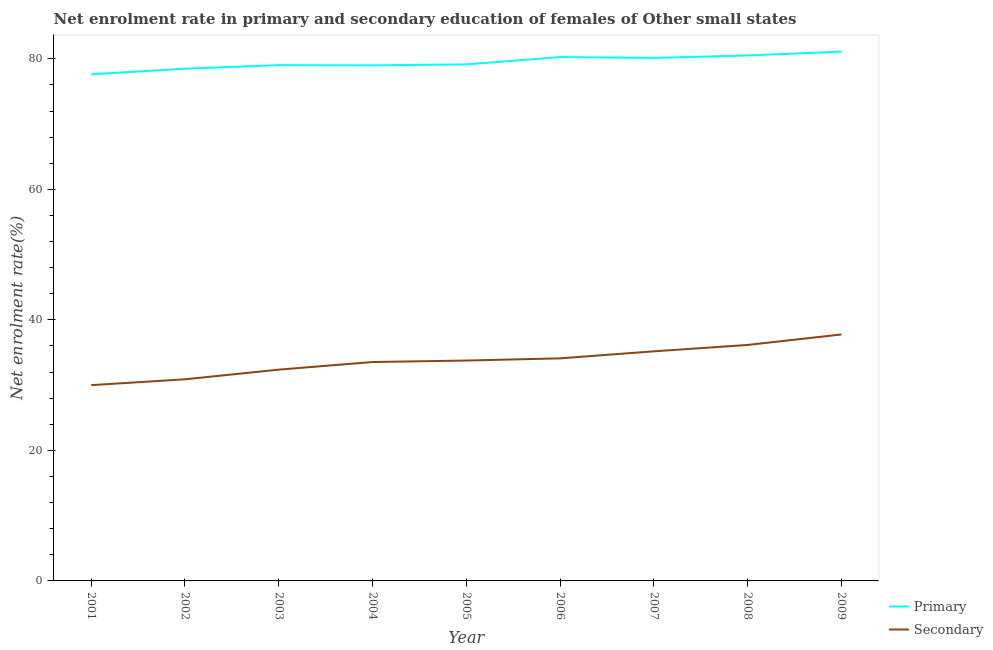Does the line corresponding to enrollment rate in primary education intersect with the line corresponding to enrollment rate in secondary education?
Give a very brief answer. No. What is the enrollment rate in primary education in 2003?
Provide a short and direct response. 79.03. Across all years, what is the maximum enrollment rate in primary education?
Provide a short and direct response. 81.11. Across all years, what is the minimum enrollment rate in secondary education?
Your answer should be compact. 30. What is the total enrollment rate in primary education in the graph?
Provide a succinct answer. 715.3. What is the difference between the enrollment rate in secondary education in 2004 and that in 2008?
Ensure brevity in your answer.  -2.61. What is the difference between the enrollment rate in primary education in 2009 and the enrollment rate in secondary education in 2007?
Your answer should be compact. 45.93. What is the average enrollment rate in primary education per year?
Ensure brevity in your answer.  79.48. In the year 2004, what is the difference between the enrollment rate in secondary education and enrollment rate in primary education?
Offer a very short reply. -45.45. In how many years, is the enrollment rate in primary education greater than 8 %?
Make the answer very short. 9. What is the ratio of the enrollment rate in primary education in 2004 to that in 2008?
Keep it short and to the point. 0.98. What is the difference between the highest and the second highest enrollment rate in primary education?
Ensure brevity in your answer.  0.6. What is the difference between the highest and the lowest enrollment rate in primary education?
Make the answer very short. 3.48. Does the enrollment rate in secondary education monotonically increase over the years?
Keep it short and to the point. Yes. Is the enrollment rate in secondary education strictly greater than the enrollment rate in primary education over the years?
Offer a very short reply. No. How many years are there in the graph?
Offer a very short reply. 9. How many legend labels are there?
Keep it short and to the point. 2. What is the title of the graph?
Your response must be concise. Net enrolment rate in primary and secondary education of females of Other small states. What is the label or title of the Y-axis?
Your response must be concise. Net enrolment rate(%). What is the Net enrolment rate(%) in Primary in 2001?
Offer a terse response. 77.63. What is the Net enrolment rate(%) of Secondary in 2001?
Your response must be concise. 30. What is the Net enrolment rate(%) of Primary in 2002?
Give a very brief answer. 78.48. What is the Net enrolment rate(%) of Secondary in 2002?
Provide a succinct answer. 30.89. What is the Net enrolment rate(%) in Primary in 2003?
Your answer should be compact. 79.03. What is the Net enrolment rate(%) of Secondary in 2003?
Keep it short and to the point. 32.37. What is the Net enrolment rate(%) of Primary in 2004?
Offer a terse response. 78.99. What is the Net enrolment rate(%) of Secondary in 2004?
Keep it short and to the point. 33.54. What is the Net enrolment rate(%) in Primary in 2005?
Your answer should be very brief. 79.15. What is the Net enrolment rate(%) of Secondary in 2005?
Offer a very short reply. 33.77. What is the Net enrolment rate(%) of Primary in 2006?
Your answer should be very brief. 80.27. What is the Net enrolment rate(%) in Secondary in 2006?
Your answer should be compact. 34.1. What is the Net enrolment rate(%) of Primary in 2007?
Keep it short and to the point. 80.14. What is the Net enrolment rate(%) in Secondary in 2007?
Your response must be concise. 35.18. What is the Net enrolment rate(%) of Primary in 2008?
Your answer should be very brief. 80.51. What is the Net enrolment rate(%) in Secondary in 2008?
Your response must be concise. 36.16. What is the Net enrolment rate(%) in Primary in 2009?
Your response must be concise. 81.11. What is the Net enrolment rate(%) in Secondary in 2009?
Make the answer very short. 37.76. Across all years, what is the maximum Net enrolment rate(%) of Primary?
Provide a short and direct response. 81.11. Across all years, what is the maximum Net enrolment rate(%) in Secondary?
Your answer should be very brief. 37.76. Across all years, what is the minimum Net enrolment rate(%) in Primary?
Your answer should be compact. 77.63. Across all years, what is the minimum Net enrolment rate(%) of Secondary?
Ensure brevity in your answer.  30. What is the total Net enrolment rate(%) of Primary in the graph?
Give a very brief answer. 715.3. What is the total Net enrolment rate(%) of Secondary in the graph?
Offer a terse response. 303.77. What is the difference between the Net enrolment rate(%) of Primary in 2001 and that in 2002?
Provide a short and direct response. -0.86. What is the difference between the Net enrolment rate(%) of Secondary in 2001 and that in 2002?
Your answer should be compact. -0.9. What is the difference between the Net enrolment rate(%) in Primary in 2001 and that in 2003?
Your answer should be compact. -1.4. What is the difference between the Net enrolment rate(%) in Secondary in 2001 and that in 2003?
Your response must be concise. -2.38. What is the difference between the Net enrolment rate(%) in Primary in 2001 and that in 2004?
Make the answer very short. -1.36. What is the difference between the Net enrolment rate(%) of Secondary in 2001 and that in 2004?
Keep it short and to the point. -3.54. What is the difference between the Net enrolment rate(%) of Primary in 2001 and that in 2005?
Provide a succinct answer. -1.52. What is the difference between the Net enrolment rate(%) in Secondary in 2001 and that in 2005?
Make the answer very short. -3.77. What is the difference between the Net enrolment rate(%) in Primary in 2001 and that in 2006?
Offer a terse response. -2.64. What is the difference between the Net enrolment rate(%) of Secondary in 2001 and that in 2006?
Offer a terse response. -4.11. What is the difference between the Net enrolment rate(%) of Primary in 2001 and that in 2007?
Offer a very short reply. -2.51. What is the difference between the Net enrolment rate(%) of Secondary in 2001 and that in 2007?
Your answer should be very brief. -5.18. What is the difference between the Net enrolment rate(%) of Primary in 2001 and that in 2008?
Your answer should be compact. -2.88. What is the difference between the Net enrolment rate(%) of Secondary in 2001 and that in 2008?
Provide a succinct answer. -6.16. What is the difference between the Net enrolment rate(%) of Primary in 2001 and that in 2009?
Your answer should be very brief. -3.48. What is the difference between the Net enrolment rate(%) in Secondary in 2001 and that in 2009?
Give a very brief answer. -7.77. What is the difference between the Net enrolment rate(%) of Primary in 2002 and that in 2003?
Make the answer very short. -0.55. What is the difference between the Net enrolment rate(%) in Secondary in 2002 and that in 2003?
Your response must be concise. -1.48. What is the difference between the Net enrolment rate(%) of Primary in 2002 and that in 2004?
Your response must be concise. -0.51. What is the difference between the Net enrolment rate(%) in Secondary in 2002 and that in 2004?
Ensure brevity in your answer.  -2.65. What is the difference between the Net enrolment rate(%) of Primary in 2002 and that in 2005?
Keep it short and to the point. -0.66. What is the difference between the Net enrolment rate(%) in Secondary in 2002 and that in 2005?
Provide a short and direct response. -2.87. What is the difference between the Net enrolment rate(%) of Primary in 2002 and that in 2006?
Keep it short and to the point. -1.78. What is the difference between the Net enrolment rate(%) in Secondary in 2002 and that in 2006?
Your response must be concise. -3.21. What is the difference between the Net enrolment rate(%) of Primary in 2002 and that in 2007?
Offer a terse response. -1.65. What is the difference between the Net enrolment rate(%) in Secondary in 2002 and that in 2007?
Make the answer very short. -4.29. What is the difference between the Net enrolment rate(%) in Primary in 2002 and that in 2008?
Offer a very short reply. -2.03. What is the difference between the Net enrolment rate(%) in Secondary in 2002 and that in 2008?
Provide a short and direct response. -5.26. What is the difference between the Net enrolment rate(%) in Primary in 2002 and that in 2009?
Give a very brief answer. -2.63. What is the difference between the Net enrolment rate(%) in Secondary in 2002 and that in 2009?
Offer a very short reply. -6.87. What is the difference between the Net enrolment rate(%) of Primary in 2003 and that in 2004?
Offer a terse response. 0.04. What is the difference between the Net enrolment rate(%) of Secondary in 2003 and that in 2004?
Make the answer very short. -1.17. What is the difference between the Net enrolment rate(%) of Primary in 2003 and that in 2005?
Offer a terse response. -0.12. What is the difference between the Net enrolment rate(%) in Secondary in 2003 and that in 2005?
Offer a very short reply. -1.4. What is the difference between the Net enrolment rate(%) of Primary in 2003 and that in 2006?
Ensure brevity in your answer.  -1.23. What is the difference between the Net enrolment rate(%) of Secondary in 2003 and that in 2006?
Ensure brevity in your answer.  -1.73. What is the difference between the Net enrolment rate(%) of Primary in 2003 and that in 2007?
Your response must be concise. -1.1. What is the difference between the Net enrolment rate(%) in Secondary in 2003 and that in 2007?
Provide a succinct answer. -2.81. What is the difference between the Net enrolment rate(%) in Primary in 2003 and that in 2008?
Your response must be concise. -1.48. What is the difference between the Net enrolment rate(%) in Secondary in 2003 and that in 2008?
Provide a succinct answer. -3.78. What is the difference between the Net enrolment rate(%) of Primary in 2003 and that in 2009?
Provide a short and direct response. -2.08. What is the difference between the Net enrolment rate(%) in Secondary in 2003 and that in 2009?
Offer a very short reply. -5.39. What is the difference between the Net enrolment rate(%) in Primary in 2004 and that in 2005?
Your response must be concise. -0.15. What is the difference between the Net enrolment rate(%) in Secondary in 2004 and that in 2005?
Provide a succinct answer. -0.23. What is the difference between the Net enrolment rate(%) of Primary in 2004 and that in 2006?
Provide a succinct answer. -1.27. What is the difference between the Net enrolment rate(%) in Secondary in 2004 and that in 2006?
Provide a succinct answer. -0.56. What is the difference between the Net enrolment rate(%) of Primary in 2004 and that in 2007?
Your answer should be compact. -1.14. What is the difference between the Net enrolment rate(%) in Secondary in 2004 and that in 2007?
Give a very brief answer. -1.64. What is the difference between the Net enrolment rate(%) of Primary in 2004 and that in 2008?
Make the answer very short. -1.52. What is the difference between the Net enrolment rate(%) in Secondary in 2004 and that in 2008?
Offer a very short reply. -2.61. What is the difference between the Net enrolment rate(%) in Primary in 2004 and that in 2009?
Provide a short and direct response. -2.12. What is the difference between the Net enrolment rate(%) in Secondary in 2004 and that in 2009?
Your answer should be very brief. -4.22. What is the difference between the Net enrolment rate(%) in Primary in 2005 and that in 2006?
Your response must be concise. -1.12. What is the difference between the Net enrolment rate(%) in Secondary in 2005 and that in 2006?
Ensure brevity in your answer.  -0.33. What is the difference between the Net enrolment rate(%) of Primary in 2005 and that in 2007?
Your answer should be very brief. -0.99. What is the difference between the Net enrolment rate(%) of Secondary in 2005 and that in 2007?
Provide a succinct answer. -1.41. What is the difference between the Net enrolment rate(%) in Primary in 2005 and that in 2008?
Offer a terse response. -1.36. What is the difference between the Net enrolment rate(%) in Secondary in 2005 and that in 2008?
Give a very brief answer. -2.39. What is the difference between the Net enrolment rate(%) of Primary in 2005 and that in 2009?
Your answer should be compact. -1.96. What is the difference between the Net enrolment rate(%) of Secondary in 2005 and that in 2009?
Offer a very short reply. -3.99. What is the difference between the Net enrolment rate(%) of Primary in 2006 and that in 2007?
Offer a very short reply. 0.13. What is the difference between the Net enrolment rate(%) of Secondary in 2006 and that in 2007?
Ensure brevity in your answer.  -1.08. What is the difference between the Net enrolment rate(%) in Primary in 2006 and that in 2008?
Offer a very short reply. -0.25. What is the difference between the Net enrolment rate(%) in Secondary in 2006 and that in 2008?
Your answer should be compact. -2.05. What is the difference between the Net enrolment rate(%) in Primary in 2006 and that in 2009?
Your answer should be very brief. -0.85. What is the difference between the Net enrolment rate(%) of Secondary in 2006 and that in 2009?
Provide a succinct answer. -3.66. What is the difference between the Net enrolment rate(%) of Primary in 2007 and that in 2008?
Make the answer very short. -0.38. What is the difference between the Net enrolment rate(%) of Secondary in 2007 and that in 2008?
Your answer should be very brief. -0.98. What is the difference between the Net enrolment rate(%) in Primary in 2007 and that in 2009?
Your answer should be very brief. -0.98. What is the difference between the Net enrolment rate(%) in Secondary in 2007 and that in 2009?
Provide a short and direct response. -2.58. What is the difference between the Net enrolment rate(%) of Primary in 2008 and that in 2009?
Provide a short and direct response. -0.6. What is the difference between the Net enrolment rate(%) of Secondary in 2008 and that in 2009?
Your response must be concise. -1.61. What is the difference between the Net enrolment rate(%) in Primary in 2001 and the Net enrolment rate(%) in Secondary in 2002?
Keep it short and to the point. 46.73. What is the difference between the Net enrolment rate(%) of Primary in 2001 and the Net enrolment rate(%) of Secondary in 2003?
Provide a short and direct response. 45.25. What is the difference between the Net enrolment rate(%) of Primary in 2001 and the Net enrolment rate(%) of Secondary in 2004?
Offer a very short reply. 44.09. What is the difference between the Net enrolment rate(%) of Primary in 2001 and the Net enrolment rate(%) of Secondary in 2005?
Offer a very short reply. 43.86. What is the difference between the Net enrolment rate(%) of Primary in 2001 and the Net enrolment rate(%) of Secondary in 2006?
Your response must be concise. 43.52. What is the difference between the Net enrolment rate(%) of Primary in 2001 and the Net enrolment rate(%) of Secondary in 2007?
Your answer should be very brief. 42.45. What is the difference between the Net enrolment rate(%) of Primary in 2001 and the Net enrolment rate(%) of Secondary in 2008?
Keep it short and to the point. 41.47. What is the difference between the Net enrolment rate(%) of Primary in 2001 and the Net enrolment rate(%) of Secondary in 2009?
Provide a short and direct response. 39.87. What is the difference between the Net enrolment rate(%) in Primary in 2002 and the Net enrolment rate(%) in Secondary in 2003?
Your answer should be very brief. 46.11. What is the difference between the Net enrolment rate(%) of Primary in 2002 and the Net enrolment rate(%) of Secondary in 2004?
Offer a very short reply. 44.94. What is the difference between the Net enrolment rate(%) in Primary in 2002 and the Net enrolment rate(%) in Secondary in 2005?
Your answer should be compact. 44.72. What is the difference between the Net enrolment rate(%) of Primary in 2002 and the Net enrolment rate(%) of Secondary in 2006?
Your response must be concise. 44.38. What is the difference between the Net enrolment rate(%) in Primary in 2002 and the Net enrolment rate(%) in Secondary in 2007?
Offer a terse response. 43.3. What is the difference between the Net enrolment rate(%) in Primary in 2002 and the Net enrolment rate(%) in Secondary in 2008?
Ensure brevity in your answer.  42.33. What is the difference between the Net enrolment rate(%) of Primary in 2002 and the Net enrolment rate(%) of Secondary in 2009?
Your response must be concise. 40.72. What is the difference between the Net enrolment rate(%) of Primary in 2003 and the Net enrolment rate(%) of Secondary in 2004?
Keep it short and to the point. 45.49. What is the difference between the Net enrolment rate(%) in Primary in 2003 and the Net enrolment rate(%) in Secondary in 2005?
Provide a short and direct response. 45.26. What is the difference between the Net enrolment rate(%) in Primary in 2003 and the Net enrolment rate(%) in Secondary in 2006?
Provide a short and direct response. 44.93. What is the difference between the Net enrolment rate(%) of Primary in 2003 and the Net enrolment rate(%) of Secondary in 2007?
Your answer should be very brief. 43.85. What is the difference between the Net enrolment rate(%) of Primary in 2003 and the Net enrolment rate(%) of Secondary in 2008?
Make the answer very short. 42.88. What is the difference between the Net enrolment rate(%) of Primary in 2003 and the Net enrolment rate(%) of Secondary in 2009?
Offer a very short reply. 41.27. What is the difference between the Net enrolment rate(%) in Primary in 2004 and the Net enrolment rate(%) in Secondary in 2005?
Your answer should be very brief. 45.22. What is the difference between the Net enrolment rate(%) of Primary in 2004 and the Net enrolment rate(%) of Secondary in 2006?
Offer a very short reply. 44.89. What is the difference between the Net enrolment rate(%) of Primary in 2004 and the Net enrolment rate(%) of Secondary in 2007?
Provide a succinct answer. 43.81. What is the difference between the Net enrolment rate(%) in Primary in 2004 and the Net enrolment rate(%) in Secondary in 2008?
Give a very brief answer. 42.84. What is the difference between the Net enrolment rate(%) of Primary in 2004 and the Net enrolment rate(%) of Secondary in 2009?
Provide a short and direct response. 41.23. What is the difference between the Net enrolment rate(%) in Primary in 2005 and the Net enrolment rate(%) in Secondary in 2006?
Offer a terse response. 45.04. What is the difference between the Net enrolment rate(%) of Primary in 2005 and the Net enrolment rate(%) of Secondary in 2007?
Your response must be concise. 43.97. What is the difference between the Net enrolment rate(%) of Primary in 2005 and the Net enrolment rate(%) of Secondary in 2008?
Provide a succinct answer. 42.99. What is the difference between the Net enrolment rate(%) of Primary in 2005 and the Net enrolment rate(%) of Secondary in 2009?
Provide a short and direct response. 41.38. What is the difference between the Net enrolment rate(%) of Primary in 2006 and the Net enrolment rate(%) of Secondary in 2007?
Offer a terse response. 45.09. What is the difference between the Net enrolment rate(%) in Primary in 2006 and the Net enrolment rate(%) in Secondary in 2008?
Ensure brevity in your answer.  44.11. What is the difference between the Net enrolment rate(%) in Primary in 2006 and the Net enrolment rate(%) in Secondary in 2009?
Offer a very short reply. 42.5. What is the difference between the Net enrolment rate(%) of Primary in 2007 and the Net enrolment rate(%) of Secondary in 2008?
Your answer should be very brief. 43.98. What is the difference between the Net enrolment rate(%) in Primary in 2007 and the Net enrolment rate(%) in Secondary in 2009?
Offer a terse response. 42.37. What is the difference between the Net enrolment rate(%) of Primary in 2008 and the Net enrolment rate(%) of Secondary in 2009?
Offer a terse response. 42.75. What is the average Net enrolment rate(%) of Primary per year?
Keep it short and to the point. 79.48. What is the average Net enrolment rate(%) of Secondary per year?
Keep it short and to the point. 33.75. In the year 2001, what is the difference between the Net enrolment rate(%) in Primary and Net enrolment rate(%) in Secondary?
Keep it short and to the point. 47.63. In the year 2002, what is the difference between the Net enrolment rate(%) in Primary and Net enrolment rate(%) in Secondary?
Keep it short and to the point. 47.59. In the year 2003, what is the difference between the Net enrolment rate(%) in Primary and Net enrolment rate(%) in Secondary?
Provide a succinct answer. 46.66. In the year 2004, what is the difference between the Net enrolment rate(%) in Primary and Net enrolment rate(%) in Secondary?
Give a very brief answer. 45.45. In the year 2005, what is the difference between the Net enrolment rate(%) in Primary and Net enrolment rate(%) in Secondary?
Make the answer very short. 45.38. In the year 2006, what is the difference between the Net enrolment rate(%) of Primary and Net enrolment rate(%) of Secondary?
Offer a terse response. 46.16. In the year 2007, what is the difference between the Net enrolment rate(%) in Primary and Net enrolment rate(%) in Secondary?
Give a very brief answer. 44.96. In the year 2008, what is the difference between the Net enrolment rate(%) in Primary and Net enrolment rate(%) in Secondary?
Make the answer very short. 44.35. In the year 2009, what is the difference between the Net enrolment rate(%) of Primary and Net enrolment rate(%) of Secondary?
Your answer should be very brief. 43.35. What is the ratio of the Net enrolment rate(%) in Secondary in 2001 to that in 2002?
Provide a succinct answer. 0.97. What is the ratio of the Net enrolment rate(%) in Primary in 2001 to that in 2003?
Offer a very short reply. 0.98. What is the ratio of the Net enrolment rate(%) in Secondary in 2001 to that in 2003?
Your answer should be compact. 0.93. What is the ratio of the Net enrolment rate(%) of Primary in 2001 to that in 2004?
Your response must be concise. 0.98. What is the ratio of the Net enrolment rate(%) in Secondary in 2001 to that in 2004?
Offer a very short reply. 0.89. What is the ratio of the Net enrolment rate(%) of Primary in 2001 to that in 2005?
Offer a terse response. 0.98. What is the ratio of the Net enrolment rate(%) of Secondary in 2001 to that in 2005?
Your answer should be very brief. 0.89. What is the ratio of the Net enrolment rate(%) in Primary in 2001 to that in 2006?
Provide a succinct answer. 0.97. What is the ratio of the Net enrolment rate(%) in Secondary in 2001 to that in 2006?
Provide a short and direct response. 0.88. What is the ratio of the Net enrolment rate(%) of Primary in 2001 to that in 2007?
Offer a terse response. 0.97. What is the ratio of the Net enrolment rate(%) in Secondary in 2001 to that in 2007?
Provide a succinct answer. 0.85. What is the ratio of the Net enrolment rate(%) of Primary in 2001 to that in 2008?
Offer a very short reply. 0.96. What is the ratio of the Net enrolment rate(%) of Secondary in 2001 to that in 2008?
Give a very brief answer. 0.83. What is the ratio of the Net enrolment rate(%) of Secondary in 2001 to that in 2009?
Your answer should be compact. 0.79. What is the ratio of the Net enrolment rate(%) in Primary in 2002 to that in 2003?
Offer a terse response. 0.99. What is the ratio of the Net enrolment rate(%) of Secondary in 2002 to that in 2003?
Your response must be concise. 0.95. What is the ratio of the Net enrolment rate(%) of Primary in 2002 to that in 2004?
Give a very brief answer. 0.99. What is the ratio of the Net enrolment rate(%) of Secondary in 2002 to that in 2004?
Your answer should be compact. 0.92. What is the ratio of the Net enrolment rate(%) in Primary in 2002 to that in 2005?
Offer a very short reply. 0.99. What is the ratio of the Net enrolment rate(%) of Secondary in 2002 to that in 2005?
Keep it short and to the point. 0.91. What is the ratio of the Net enrolment rate(%) in Primary in 2002 to that in 2006?
Keep it short and to the point. 0.98. What is the ratio of the Net enrolment rate(%) of Secondary in 2002 to that in 2006?
Your answer should be very brief. 0.91. What is the ratio of the Net enrolment rate(%) in Primary in 2002 to that in 2007?
Keep it short and to the point. 0.98. What is the ratio of the Net enrolment rate(%) in Secondary in 2002 to that in 2007?
Keep it short and to the point. 0.88. What is the ratio of the Net enrolment rate(%) in Primary in 2002 to that in 2008?
Offer a terse response. 0.97. What is the ratio of the Net enrolment rate(%) in Secondary in 2002 to that in 2008?
Keep it short and to the point. 0.85. What is the ratio of the Net enrolment rate(%) of Primary in 2002 to that in 2009?
Provide a short and direct response. 0.97. What is the ratio of the Net enrolment rate(%) of Secondary in 2002 to that in 2009?
Give a very brief answer. 0.82. What is the ratio of the Net enrolment rate(%) in Primary in 2003 to that in 2004?
Give a very brief answer. 1. What is the ratio of the Net enrolment rate(%) in Secondary in 2003 to that in 2004?
Make the answer very short. 0.97. What is the ratio of the Net enrolment rate(%) in Primary in 2003 to that in 2005?
Offer a terse response. 1. What is the ratio of the Net enrolment rate(%) of Secondary in 2003 to that in 2005?
Your response must be concise. 0.96. What is the ratio of the Net enrolment rate(%) of Primary in 2003 to that in 2006?
Provide a succinct answer. 0.98. What is the ratio of the Net enrolment rate(%) of Secondary in 2003 to that in 2006?
Your answer should be very brief. 0.95. What is the ratio of the Net enrolment rate(%) in Primary in 2003 to that in 2007?
Give a very brief answer. 0.99. What is the ratio of the Net enrolment rate(%) of Secondary in 2003 to that in 2007?
Your answer should be very brief. 0.92. What is the ratio of the Net enrolment rate(%) of Primary in 2003 to that in 2008?
Offer a terse response. 0.98. What is the ratio of the Net enrolment rate(%) in Secondary in 2003 to that in 2008?
Make the answer very short. 0.9. What is the ratio of the Net enrolment rate(%) in Primary in 2003 to that in 2009?
Make the answer very short. 0.97. What is the ratio of the Net enrolment rate(%) of Secondary in 2003 to that in 2009?
Offer a terse response. 0.86. What is the ratio of the Net enrolment rate(%) in Secondary in 2004 to that in 2005?
Provide a short and direct response. 0.99. What is the ratio of the Net enrolment rate(%) in Primary in 2004 to that in 2006?
Give a very brief answer. 0.98. What is the ratio of the Net enrolment rate(%) in Secondary in 2004 to that in 2006?
Offer a very short reply. 0.98. What is the ratio of the Net enrolment rate(%) in Primary in 2004 to that in 2007?
Provide a short and direct response. 0.99. What is the ratio of the Net enrolment rate(%) of Secondary in 2004 to that in 2007?
Your answer should be compact. 0.95. What is the ratio of the Net enrolment rate(%) in Primary in 2004 to that in 2008?
Offer a very short reply. 0.98. What is the ratio of the Net enrolment rate(%) in Secondary in 2004 to that in 2008?
Keep it short and to the point. 0.93. What is the ratio of the Net enrolment rate(%) in Primary in 2004 to that in 2009?
Make the answer very short. 0.97. What is the ratio of the Net enrolment rate(%) of Secondary in 2004 to that in 2009?
Keep it short and to the point. 0.89. What is the ratio of the Net enrolment rate(%) of Primary in 2005 to that in 2006?
Offer a terse response. 0.99. What is the ratio of the Net enrolment rate(%) in Secondary in 2005 to that in 2006?
Offer a terse response. 0.99. What is the ratio of the Net enrolment rate(%) in Secondary in 2005 to that in 2007?
Provide a short and direct response. 0.96. What is the ratio of the Net enrolment rate(%) in Secondary in 2005 to that in 2008?
Provide a short and direct response. 0.93. What is the ratio of the Net enrolment rate(%) of Primary in 2005 to that in 2009?
Your answer should be compact. 0.98. What is the ratio of the Net enrolment rate(%) of Secondary in 2005 to that in 2009?
Your answer should be very brief. 0.89. What is the ratio of the Net enrolment rate(%) of Primary in 2006 to that in 2007?
Ensure brevity in your answer.  1. What is the ratio of the Net enrolment rate(%) in Secondary in 2006 to that in 2007?
Offer a very short reply. 0.97. What is the ratio of the Net enrolment rate(%) in Secondary in 2006 to that in 2008?
Your answer should be very brief. 0.94. What is the ratio of the Net enrolment rate(%) of Primary in 2006 to that in 2009?
Offer a terse response. 0.99. What is the ratio of the Net enrolment rate(%) of Secondary in 2006 to that in 2009?
Your answer should be compact. 0.9. What is the ratio of the Net enrolment rate(%) in Secondary in 2007 to that in 2008?
Provide a short and direct response. 0.97. What is the ratio of the Net enrolment rate(%) of Secondary in 2007 to that in 2009?
Provide a short and direct response. 0.93. What is the ratio of the Net enrolment rate(%) in Secondary in 2008 to that in 2009?
Give a very brief answer. 0.96. What is the difference between the highest and the second highest Net enrolment rate(%) of Primary?
Ensure brevity in your answer.  0.6. What is the difference between the highest and the second highest Net enrolment rate(%) in Secondary?
Provide a succinct answer. 1.61. What is the difference between the highest and the lowest Net enrolment rate(%) in Primary?
Offer a terse response. 3.48. What is the difference between the highest and the lowest Net enrolment rate(%) in Secondary?
Give a very brief answer. 7.77. 